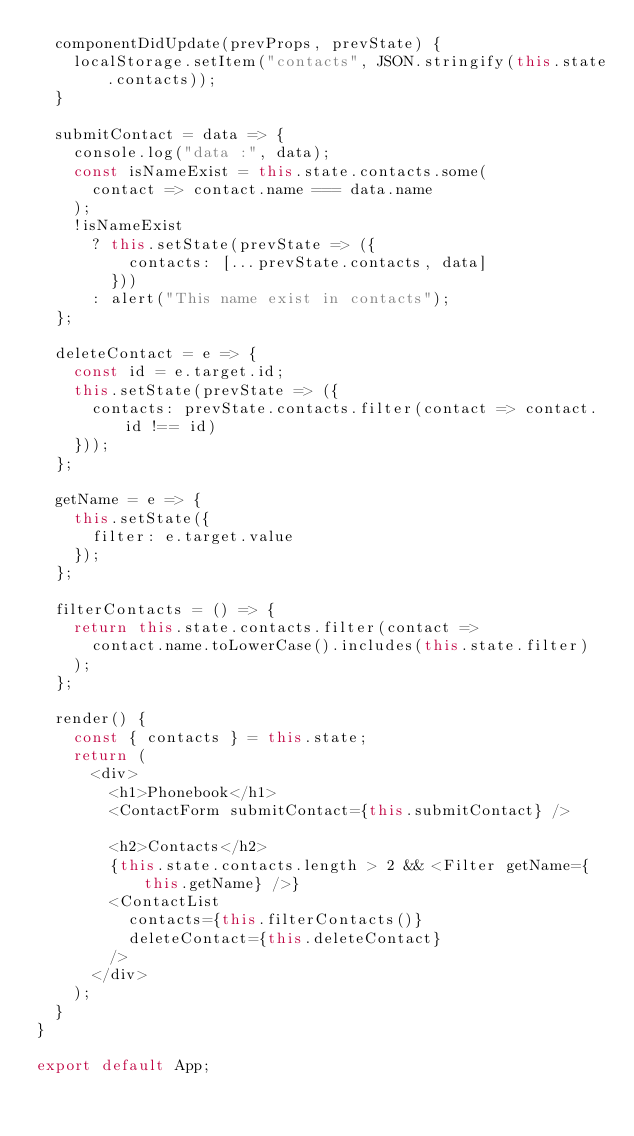Convert code to text. <code><loc_0><loc_0><loc_500><loc_500><_JavaScript_>  componentDidUpdate(prevProps, prevState) {
    localStorage.setItem("contacts", JSON.stringify(this.state.contacts));
  }

  submitContact = data => {
    console.log("data :", data);
    const isNameExist = this.state.contacts.some(
      contact => contact.name === data.name
    );
    !isNameExist
      ? this.setState(prevState => ({
          contacts: [...prevState.contacts, data]
        }))
      : alert("This name exist in contacts");
  };

  deleteContact = e => {
    const id = e.target.id;
    this.setState(prevState => ({
      contacts: prevState.contacts.filter(contact => contact.id !== id)
    }));
  };

  getName = e => {
    this.setState({
      filter: e.target.value
    });
  };

  filterContacts = () => {
    return this.state.contacts.filter(contact =>
      contact.name.toLowerCase().includes(this.state.filter)
    );
  };

  render() {
    const { contacts } = this.state;
    return (
      <div>
        <h1>Phonebook</h1>
        <ContactForm submitContact={this.submitContact} />

        <h2>Contacts</h2>
        {this.state.contacts.length > 2 && <Filter getName={this.getName} />}
        <ContactList
          contacts={this.filterContacts()}
          deleteContact={this.deleteContact}
        />
      </div>
    );
  }
}

export default App;
</code> 